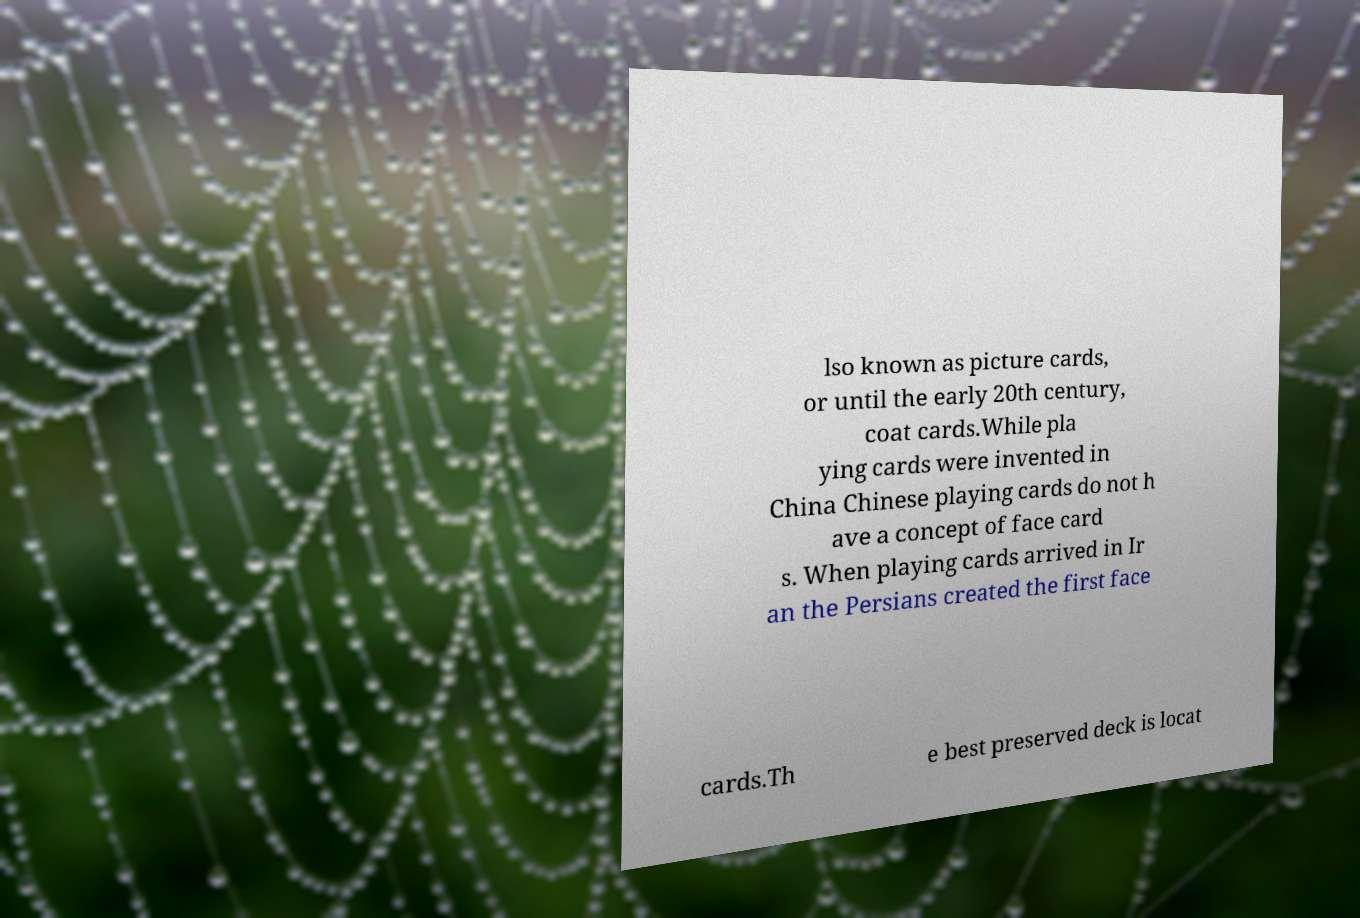Can you accurately transcribe the text from the provided image for me? lso known as picture cards, or until the early 20th century, coat cards.While pla ying cards were invented in China Chinese playing cards do not h ave a concept of face card s. When playing cards arrived in Ir an the Persians created the first face cards.Th e best preserved deck is locat 